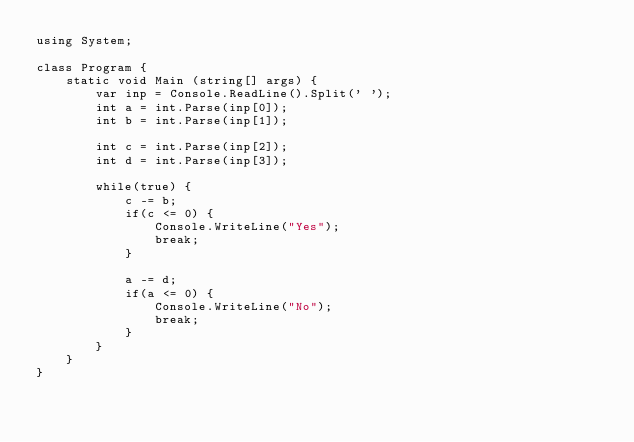Convert code to text. <code><loc_0><loc_0><loc_500><loc_500><_C#_>using System;

class Program {
    static void Main (string[] args) {
        var inp = Console.ReadLine().Split(' ');
        int a = int.Parse(inp[0]);
        int b = int.Parse(inp[1]);

        int c = int.Parse(inp[2]);
        int d = int.Parse(inp[3]);

        while(true) {
            c -= b;
            if(c <= 0) {
                Console.WriteLine("Yes");
                break;
            }

            a -= d;
            if(a <= 0) {
                Console.WriteLine("No");
                break;
            }
        }
    }
}</code> 